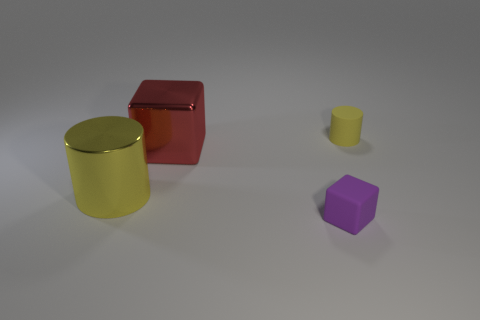Add 3 large shiny cubes. How many objects exist? 7 Subtract 1 cylinders. How many cylinders are left? 1 Subtract all gray cubes. Subtract all green balls. How many cubes are left? 2 Subtract 0 cyan blocks. How many objects are left? 4 Subtract all large yellow rubber cylinders. Subtract all purple rubber objects. How many objects are left? 3 Add 4 small rubber cylinders. How many small rubber cylinders are left? 5 Add 2 big blocks. How many big blocks exist? 3 